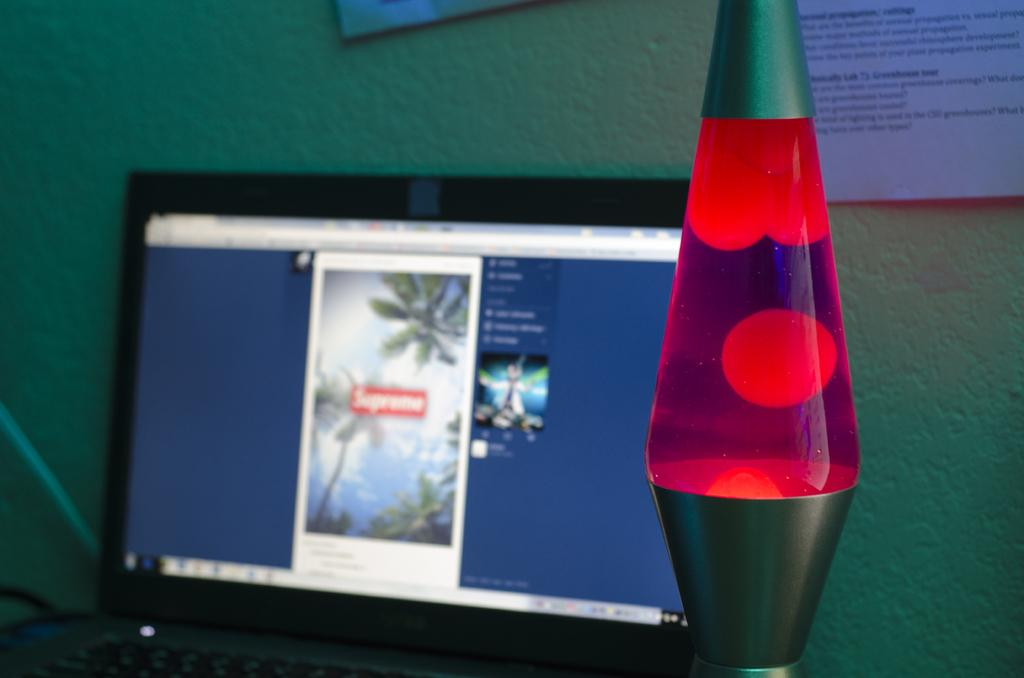Provide a one-sentence caption for the provided image. A laptop in the background with a image saying supreme. 